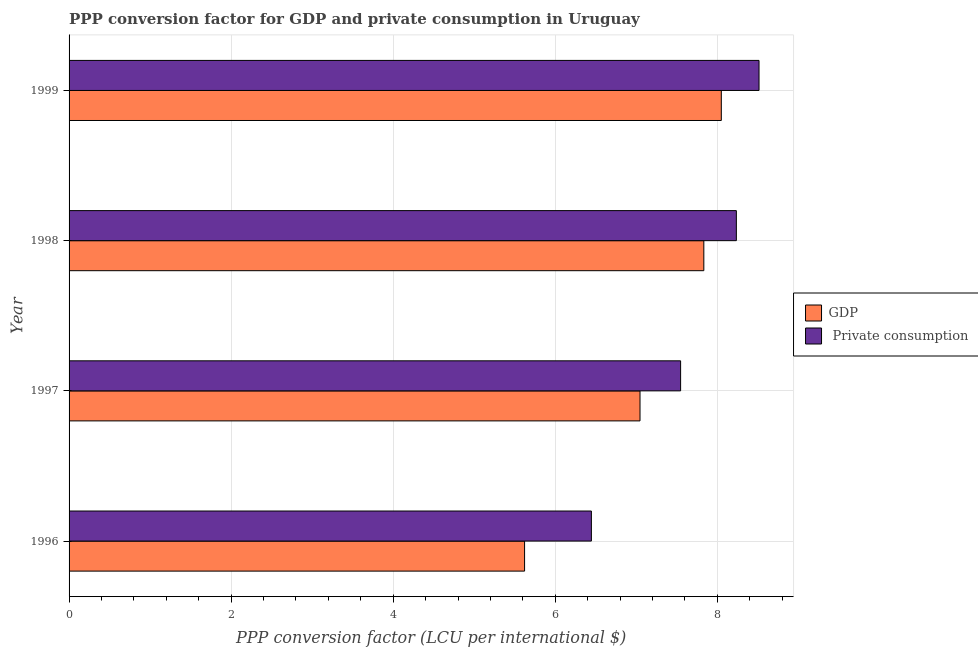How many groups of bars are there?
Offer a terse response. 4. Are the number of bars on each tick of the Y-axis equal?
Offer a very short reply. Yes. What is the label of the 4th group of bars from the top?
Ensure brevity in your answer.  1996. In how many cases, is the number of bars for a given year not equal to the number of legend labels?
Ensure brevity in your answer.  0. What is the ppp conversion factor for private consumption in 1998?
Provide a succinct answer. 8.23. Across all years, what is the maximum ppp conversion factor for gdp?
Ensure brevity in your answer.  8.05. Across all years, what is the minimum ppp conversion factor for gdp?
Offer a very short reply. 5.62. In which year was the ppp conversion factor for gdp maximum?
Offer a very short reply. 1999. In which year was the ppp conversion factor for private consumption minimum?
Your answer should be compact. 1996. What is the total ppp conversion factor for gdp in the graph?
Your response must be concise. 28.55. What is the difference between the ppp conversion factor for private consumption in 1996 and that in 1999?
Keep it short and to the point. -2.07. What is the difference between the ppp conversion factor for gdp in 1998 and the ppp conversion factor for private consumption in 1999?
Your answer should be very brief. -0.68. What is the average ppp conversion factor for gdp per year?
Provide a succinct answer. 7.14. In the year 1998, what is the difference between the ppp conversion factor for gdp and ppp conversion factor for private consumption?
Provide a succinct answer. -0.4. What is the ratio of the ppp conversion factor for private consumption in 1996 to that in 1999?
Ensure brevity in your answer.  0.76. Is the ppp conversion factor for private consumption in 1996 less than that in 1997?
Provide a succinct answer. Yes. Is the difference between the ppp conversion factor for gdp in 1998 and 1999 greater than the difference between the ppp conversion factor for private consumption in 1998 and 1999?
Your response must be concise. Yes. What is the difference between the highest and the second highest ppp conversion factor for private consumption?
Your response must be concise. 0.28. What is the difference between the highest and the lowest ppp conversion factor for gdp?
Provide a succinct answer. 2.43. In how many years, is the ppp conversion factor for gdp greater than the average ppp conversion factor for gdp taken over all years?
Your response must be concise. 2. Is the sum of the ppp conversion factor for gdp in 1996 and 1998 greater than the maximum ppp conversion factor for private consumption across all years?
Provide a short and direct response. Yes. What does the 1st bar from the top in 1996 represents?
Ensure brevity in your answer.   Private consumption. What does the 2nd bar from the bottom in 1999 represents?
Provide a succinct answer.  Private consumption. Are all the bars in the graph horizontal?
Offer a terse response. Yes. How many years are there in the graph?
Offer a terse response. 4. What is the difference between two consecutive major ticks on the X-axis?
Give a very brief answer. 2. Does the graph contain grids?
Your answer should be very brief. Yes. Where does the legend appear in the graph?
Ensure brevity in your answer.  Center right. How are the legend labels stacked?
Provide a succinct answer. Vertical. What is the title of the graph?
Give a very brief answer. PPP conversion factor for GDP and private consumption in Uruguay. Does "Excluding technical cooperation" appear as one of the legend labels in the graph?
Provide a short and direct response. No. What is the label or title of the X-axis?
Provide a succinct answer. PPP conversion factor (LCU per international $). What is the PPP conversion factor (LCU per international $) of GDP in 1996?
Your answer should be compact. 5.62. What is the PPP conversion factor (LCU per international $) of  Private consumption in 1996?
Your answer should be very brief. 6.45. What is the PPP conversion factor (LCU per international $) of GDP in 1997?
Provide a succinct answer. 7.05. What is the PPP conversion factor (LCU per international $) in  Private consumption in 1997?
Offer a very short reply. 7.55. What is the PPP conversion factor (LCU per international $) of GDP in 1998?
Ensure brevity in your answer.  7.83. What is the PPP conversion factor (LCU per international $) of  Private consumption in 1998?
Offer a terse response. 8.23. What is the PPP conversion factor (LCU per international $) in GDP in 1999?
Give a very brief answer. 8.05. What is the PPP conversion factor (LCU per international $) in  Private consumption in 1999?
Your response must be concise. 8.51. Across all years, what is the maximum PPP conversion factor (LCU per international $) in GDP?
Give a very brief answer. 8.05. Across all years, what is the maximum PPP conversion factor (LCU per international $) in  Private consumption?
Your answer should be compact. 8.51. Across all years, what is the minimum PPP conversion factor (LCU per international $) of GDP?
Give a very brief answer. 5.62. Across all years, what is the minimum PPP conversion factor (LCU per international $) in  Private consumption?
Ensure brevity in your answer.  6.45. What is the total PPP conversion factor (LCU per international $) of GDP in the graph?
Ensure brevity in your answer.  28.55. What is the total PPP conversion factor (LCU per international $) in  Private consumption in the graph?
Give a very brief answer. 30.74. What is the difference between the PPP conversion factor (LCU per international $) in GDP in 1996 and that in 1997?
Offer a very short reply. -1.42. What is the difference between the PPP conversion factor (LCU per international $) in  Private consumption in 1996 and that in 1997?
Provide a short and direct response. -1.1. What is the difference between the PPP conversion factor (LCU per international $) in GDP in 1996 and that in 1998?
Your answer should be very brief. -2.21. What is the difference between the PPP conversion factor (LCU per international $) of  Private consumption in 1996 and that in 1998?
Give a very brief answer. -1.79. What is the difference between the PPP conversion factor (LCU per international $) of GDP in 1996 and that in 1999?
Your answer should be compact. -2.43. What is the difference between the PPP conversion factor (LCU per international $) of  Private consumption in 1996 and that in 1999?
Your answer should be compact. -2.07. What is the difference between the PPP conversion factor (LCU per international $) in GDP in 1997 and that in 1998?
Ensure brevity in your answer.  -0.79. What is the difference between the PPP conversion factor (LCU per international $) of  Private consumption in 1997 and that in 1998?
Provide a short and direct response. -0.69. What is the difference between the PPP conversion factor (LCU per international $) in GDP in 1997 and that in 1999?
Your answer should be very brief. -1. What is the difference between the PPP conversion factor (LCU per international $) in  Private consumption in 1997 and that in 1999?
Keep it short and to the point. -0.97. What is the difference between the PPP conversion factor (LCU per international $) of GDP in 1998 and that in 1999?
Offer a terse response. -0.22. What is the difference between the PPP conversion factor (LCU per international $) of  Private consumption in 1998 and that in 1999?
Keep it short and to the point. -0.28. What is the difference between the PPP conversion factor (LCU per international $) of GDP in 1996 and the PPP conversion factor (LCU per international $) of  Private consumption in 1997?
Give a very brief answer. -1.93. What is the difference between the PPP conversion factor (LCU per international $) in GDP in 1996 and the PPP conversion factor (LCU per international $) in  Private consumption in 1998?
Give a very brief answer. -2.61. What is the difference between the PPP conversion factor (LCU per international $) in GDP in 1996 and the PPP conversion factor (LCU per international $) in  Private consumption in 1999?
Ensure brevity in your answer.  -2.89. What is the difference between the PPP conversion factor (LCU per international $) of GDP in 1997 and the PPP conversion factor (LCU per international $) of  Private consumption in 1998?
Provide a succinct answer. -1.19. What is the difference between the PPP conversion factor (LCU per international $) of GDP in 1997 and the PPP conversion factor (LCU per international $) of  Private consumption in 1999?
Keep it short and to the point. -1.47. What is the difference between the PPP conversion factor (LCU per international $) of GDP in 1998 and the PPP conversion factor (LCU per international $) of  Private consumption in 1999?
Ensure brevity in your answer.  -0.68. What is the average PPP conversion factor (LCU per international $) of GDP per year?
Keep it short and to the point. 7.14. What is the average PPP conversion factor (LCU per international $) in  Private consumption per year?
Give a very brief answer. 7.68. In the year 1996, what is the difference between the PPP conversion factor (LCU per international $) in GDP and PPP conversion factor (LCU per international $) in  Private consumption?
Ensure brevity in your answer.  -0.82. In the year 1997, what is the difference between the PPP conversion factor (LCU per international $) in GDP and PPP conversion factor (LCU per international $) in  Private consumption?
Your answer should be compact. -0.5. In the year 1998, what is the difference between the PPP conversion factor (LCU per international $) in GDP and PPP conversion factor (LCU per international $) in  Private consumption?
Offer a very short reply. -0.4. In the year 1999, what is the difference between the PPP conversion factor (LCU per international $) of GDP and PPP conversion factor (LCU per international $) of  Private consumption?
Keep it short and to the point. -0.47. What is the ratio of the PPP conversion factor (LCU per international $) of GDP in 1996 to that in 1997?
Your response must be concise. 0.8. What is the ratio of the PPP conversion factor (LCU per international $) of  Private consumption in 1996 to that in 1997?
Give a very brief answer. 0.85. What is the ratio of the PPP conversion factor (LCU per international $) of GDP in 1996 to that in 1998?
Keep it short and to the point. 0.72. What is the ratio of the PPP conversion factor (LCU per international $) of  Private consumption in 1996 to that in 1998?
Give a very brief answer. 0.78. What is the ratio of the PPP conversion factor (LCU per international $) in GDP in 1996 to that in 1999?
Provide a succinct answer. 0.7. What is the ratio of the PPP conversion factor (LCU per international $) in  Private consumption in 1996 to that in 1999?
Offer a very short reply. 0.76. What is the ratio of the PPP conversion factor (LCU per international $) of GDP in 1997 to that in 1998?
Offer a very short reply. 0.9. What is the ratio of the PPP conversion factor (LCU per international $) in  Private consumption in 1997 to that in 1998?
Provide a short and direct response. 0.92. What is the ratio of the PPP conversion factor (LCU per international $) in GDP in 1997 to that in 1999?
Provide a short and direct response. 0.88. What is the ratio of the PPP conversion factor (LCU per international $) of  Private consumption in 1997 to that in 1999?
Ensure brevity in your answer.  0.89. What is the ratio of the PPP conversion factor (LCU per international $) of GDP in 1998 to that in 1999?
Your answer should be very brief. 0.97. What is the ratio of the PPP conversion factor (LCU per international $) in  Private consumption in 1998 to that in 1999?
Keep it short and to the point. 0.97. What is the difference between the highest and the second highest PPP conversion factor (LCU per international $) in GDP?
Your answer should be compact. 0.22. What is the difference between the highest and the second highest PPP conversion factor (LCU per international $) of  Private consumption?
Offer a terse response. 0.28. What is the difference between the highest and the lowest PPP conversion factor (LCU per international $) of GDP?
Provide a short and direct response. 2.43. What is the difference between the highest and the lowest PPP conversion factor (LCU per international $) of  Private consumption?
Your answer should be very brief. 2.07. 